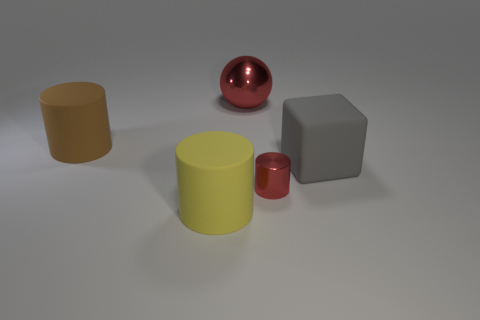Is there any other thing that has the same size as the red cylinder?
Keep it short and to the point. No. There is a thing that is both left of the big red metal thing and behind the gray rubber object; what is its size?
Offer a terse response. Large. The yellow thing that is the same size as the gray block is what shape?
Give a very brief answer. Cylinder. What is the object to the left of the thing that is in front of the metal thing that is on the right side of the big red metallic object made of?
Your response must be concise. Rubber. There is a matte thing to the left of the yellow matte object; does it have the same shape as the large matte thing that is on the right side of the yellow matte cylinder?
Make the answer very short. No. What number of other objects are the same material as the small cylinder?
Keep it short and to the point. 1. Is the big cylinder that is behind the gray block made of the same material as the red object in front of the gray object?
Your answer should be compact. No. The yellow thing that is made of the same material as the big brown cylinder is what shape?
Give a very brief answer. Cylinder. Is there anything else that has the same color as the shiny cylinder?
Ensure brevity in your answer.  Yes. How many large yellow cubes are there?
Your response must be concise. 0. 